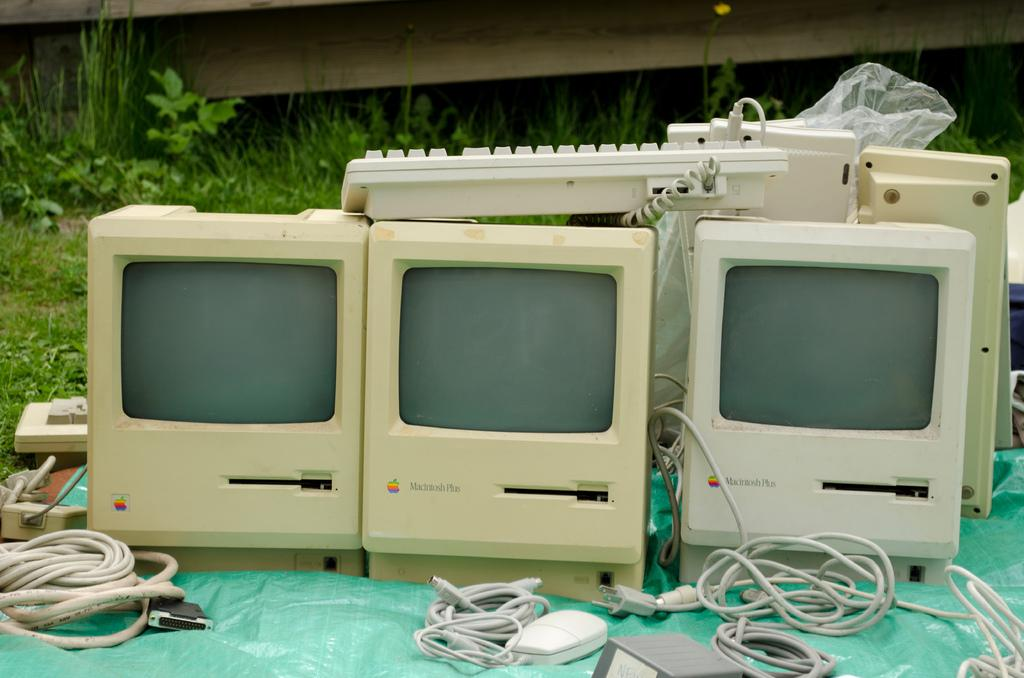What is located at the bottom of the image? There is a cover at the bottom of the image. What electronic devices are visible in the image? There are three monitors and keyboards present in the image. What input device is visible in the image? There is a mouse in the image. Are there any visible connections between the devices in the image? Wires are visible in the image. What can be seen in the background of the image? There are plants in the background of the image. How many pigs are visible in the image? There are no pigs present in the image. What type of mountain can be seen in the background of the image? There is no mountain visible in the image; it features plants in the background. 